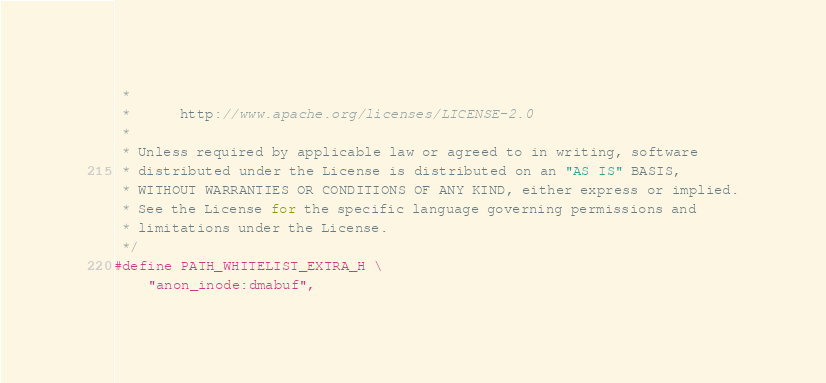<code> <loc_0><loc_0><loc_500><loc_500><_C_> *
 *      http://www.apache.org/licenses/LICENSE-2.0
 *
 * Unless required by applicable law or agreed to in writing, software
 * distributed under the License is distributed on an "AS IS" BASIS,
 * WITHOUT WARRANTIES OR CONDITIONS OF ANY KIND, either express or implied.
 * See the License for the specific language governing permissions and
 * limitations under the License.
 */
#define PATH_WHITELIST_EXTRA_H \
    "anon_inode:dmabuf",
</code> 